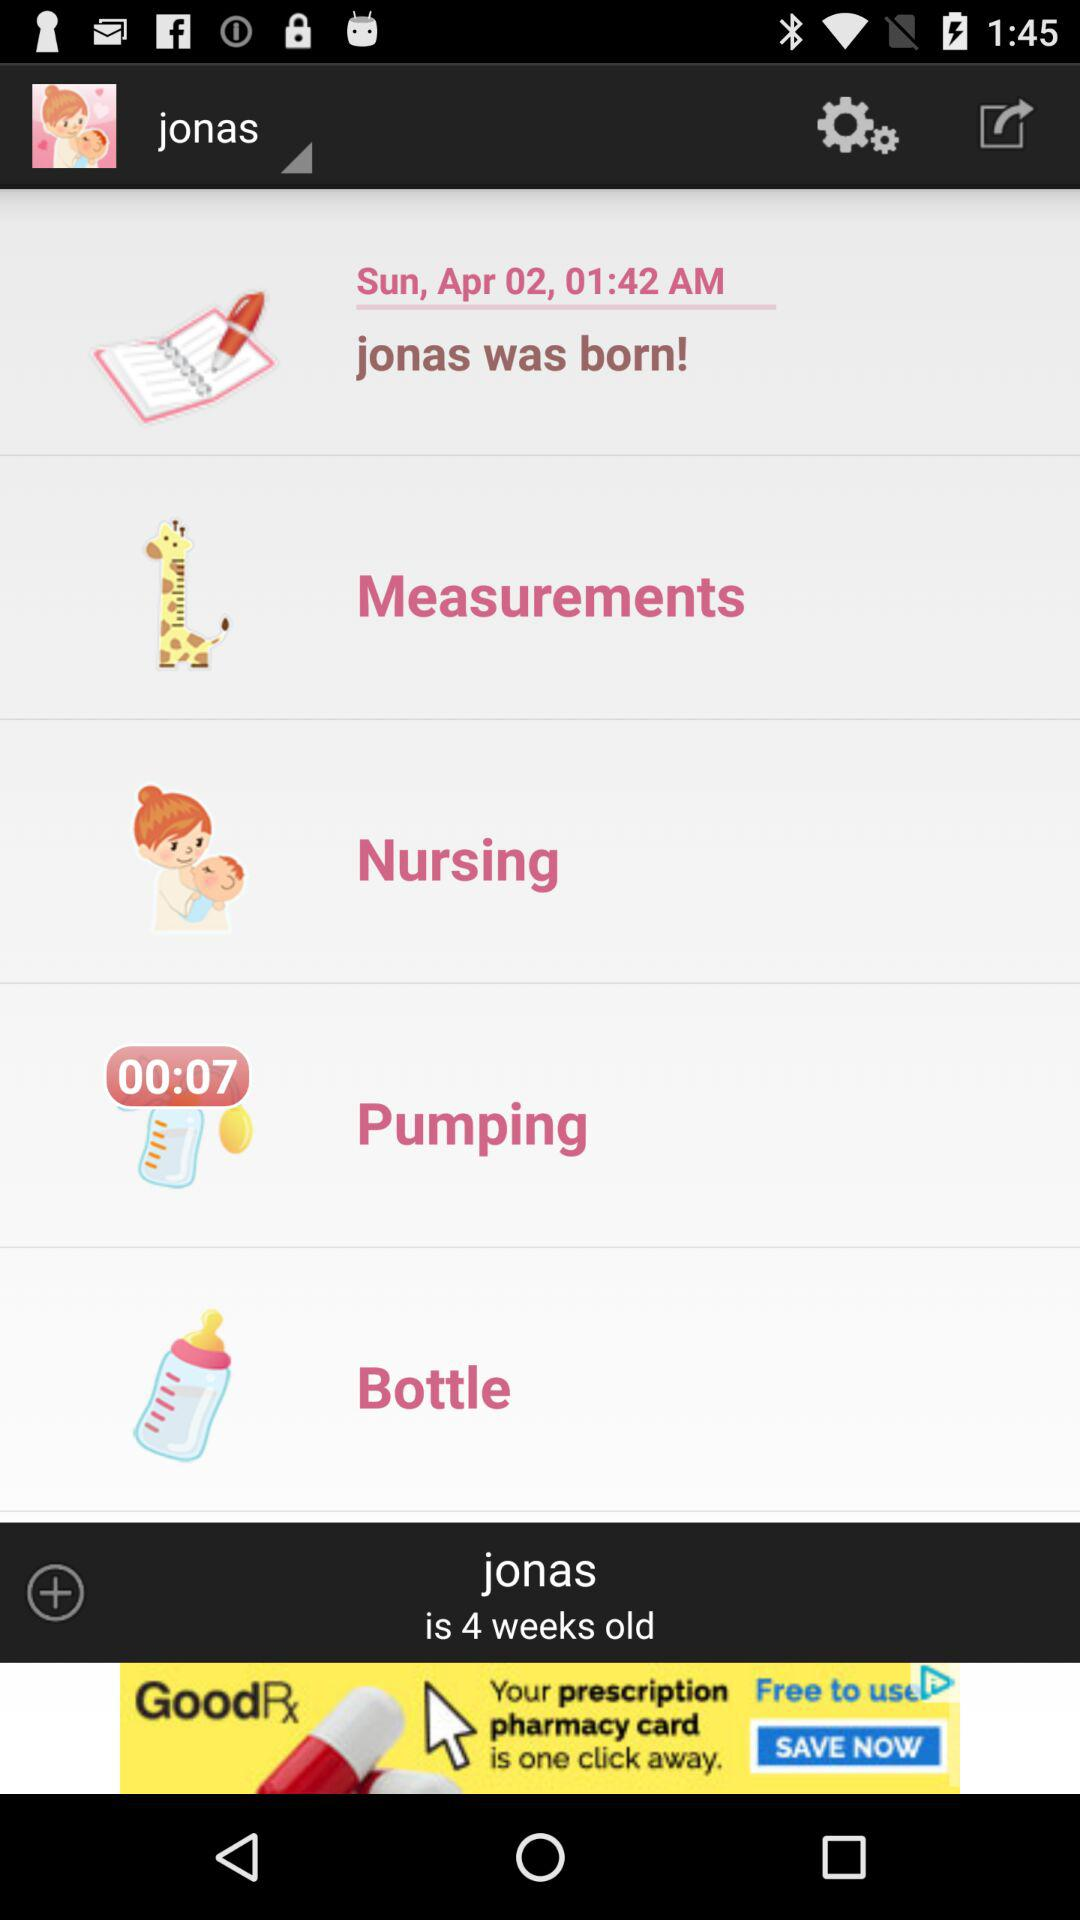How long did the pumping last? The pumping lasted for 00:07. 